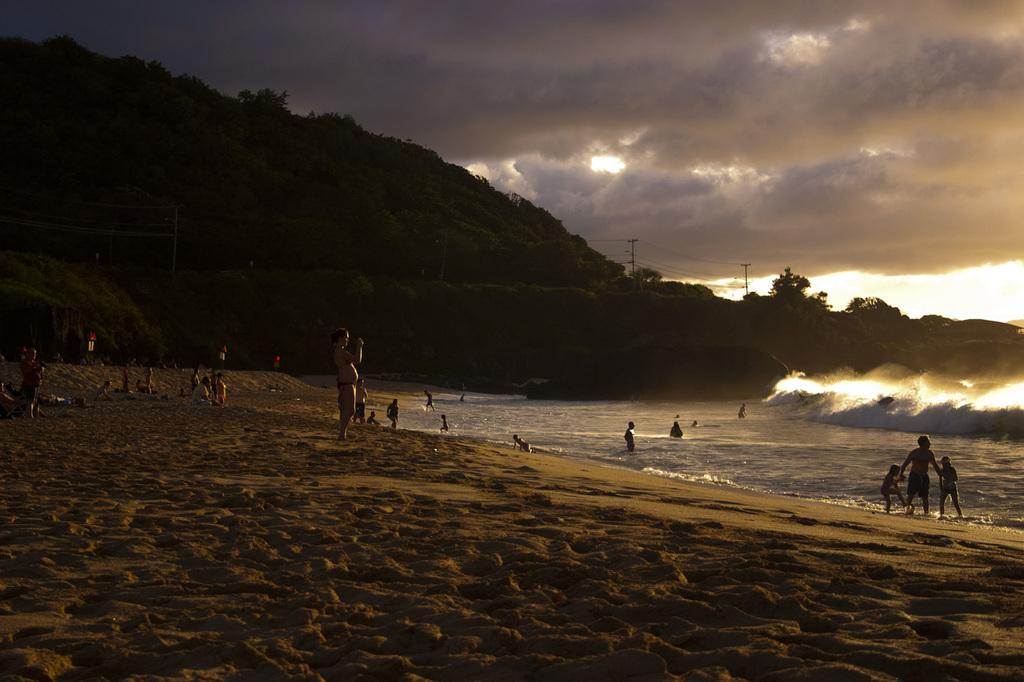What is the main setting of the image? The main setting of the image is a beach. What can be seen on the right side of the image? There is an ocean on the right side of the image. What is visible in the background of the image? There is a hill with trees in the background of the image. What is visible above the hill? The sky is visible above the hill. What type of creature is using the apparatus on the beach in the image? There is no creature or apparatus present in the image; it features people standing on a beach with an ocean, a hill with trees, and a visible sky. 